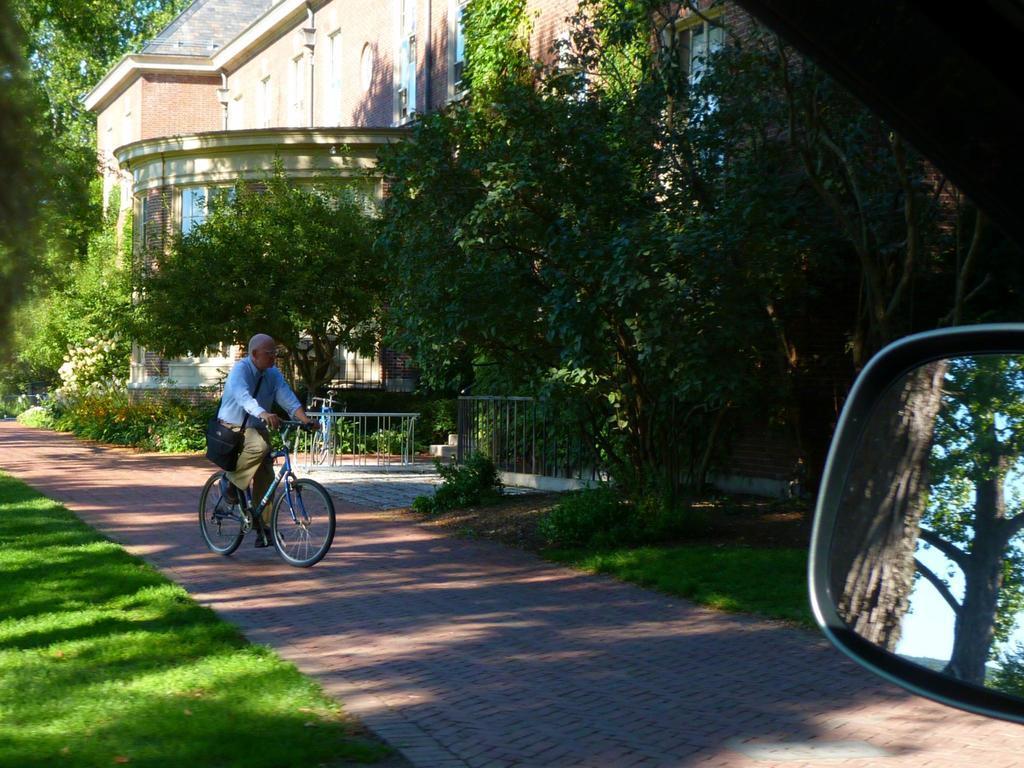Could you give a brief overview of what you see in this image? In this image we can see a person wearing blue color shirt, cream color pant also carrying messenger bag riding bicycle through the walkway there are some trees on left and right side of the image and in the background of the image there are some houses, on bottom right of the image we can see side mirror of a car. 